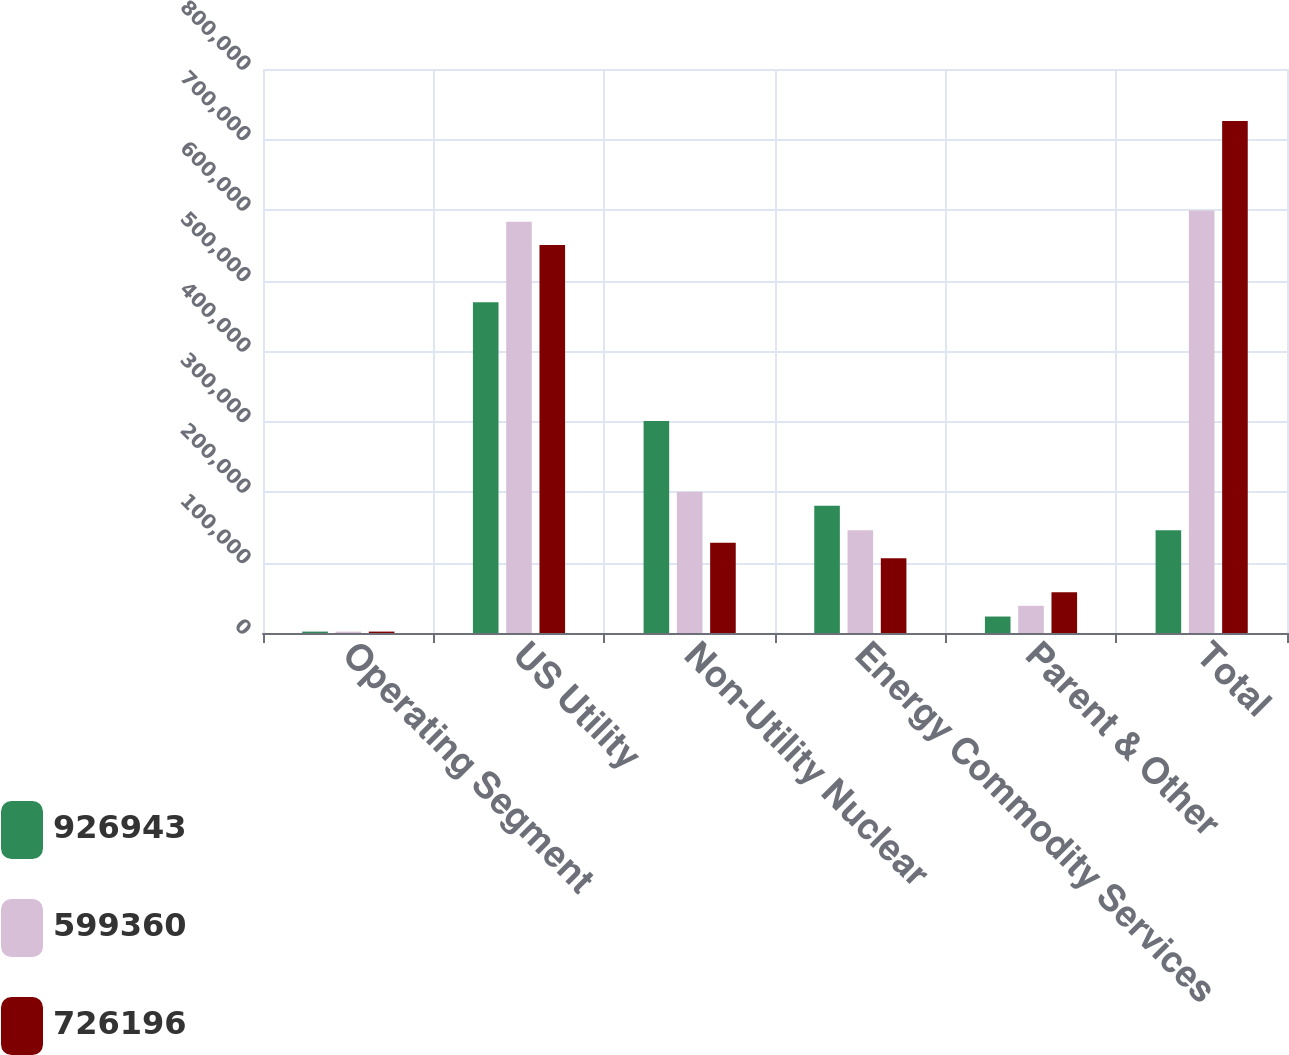Convert chart. <chart><loc_0><loc_0><loc_500><loc_500><stacked_bar_chart><ecel><fcel>Operating Segment<fcel>US Utility<fcel>Non-Utility Nuclear<fcel>Energy Commodity Services<fcel>Parent & Other<fcel>Total<nl><fcel>926943<fcel>2003<fcel>469050<fcel>300799<fcel>180454<fcel>23360<fcel>145830<nl><fcel>599360<fcel>2002<fcel>583251<fcel>200505<fcel>145830<fcel>38566<fcel>599360<nl><fcel>726196<fcel>2001<fcel>550243<fcel>127880<fcel>105939<fcel>57866<fcel>726196<nl></chart> 